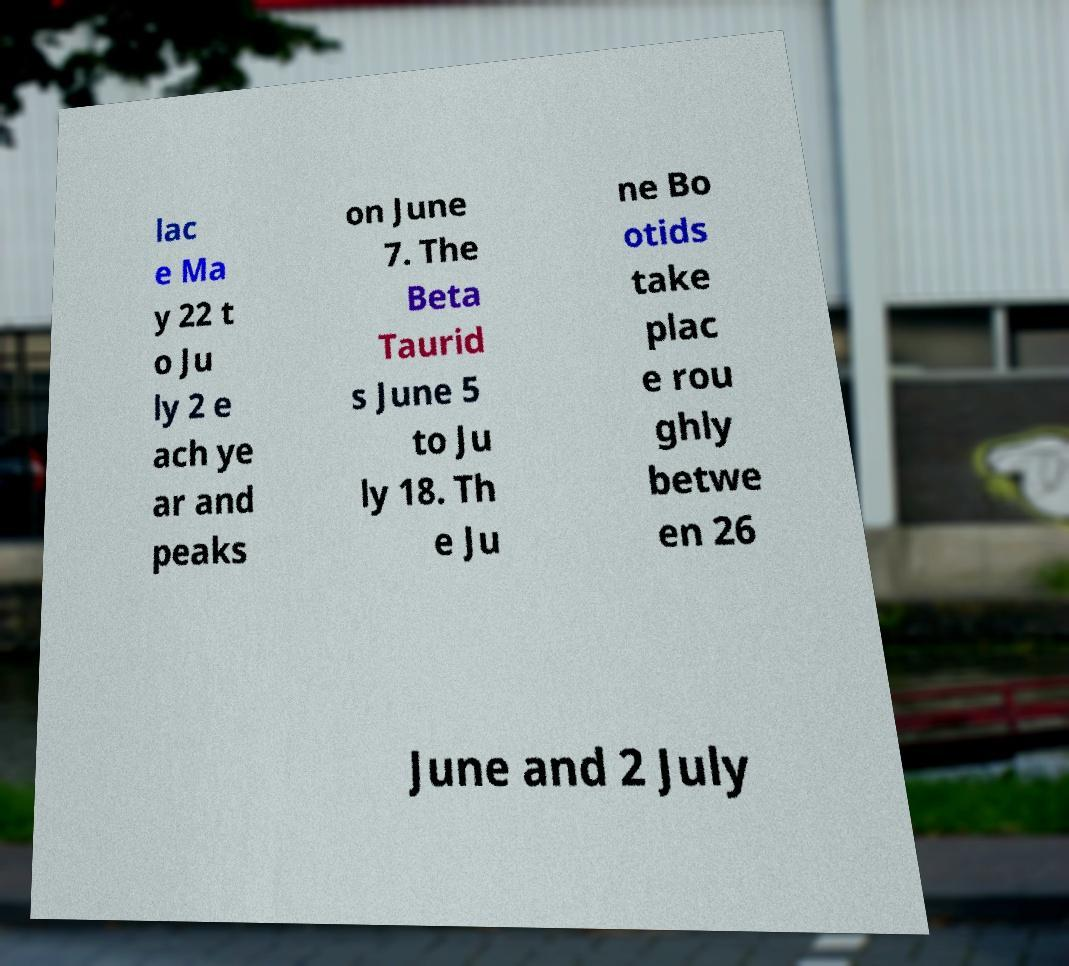Please identify and transcribe the text found in this image. lac e Ma y 22 t o Ju ly 2 e ach ye ar and peaks on June 7. The Beta Taurid s June 5 to Ju ly 18. Th e Ju ne Bo otids take plac e rou ghly betwe en 26 June and 2 July 